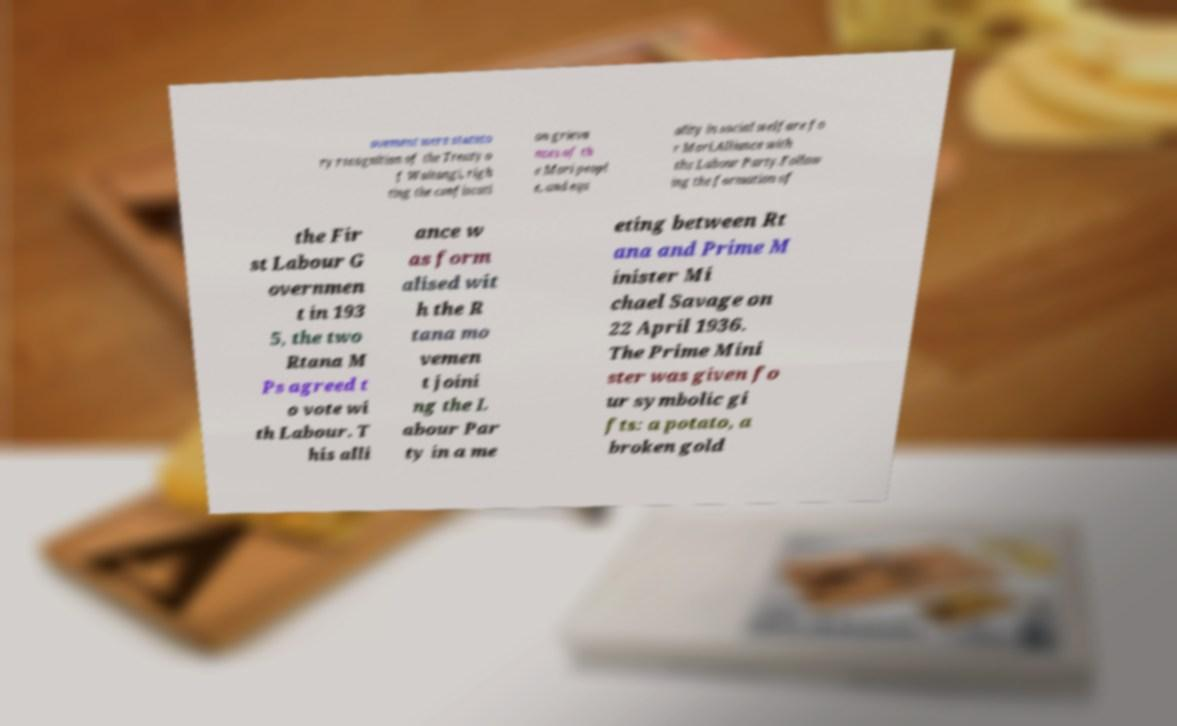For documentation purposes, I need the text within this image transcribed. Could you provide that? ovement were statuto ry recognition of the Treaty o f Waitangi, righ ting the confiscati on grieva nces of th e Mori peopl e, and equ ality in social welfare fo r Mori.Alliance with the Labour Party.Follow ing the formation of the Fir st Labour G overnmen t in 193 5, the two Rtana M Ps agreed t o vote wi th Labour. T his alli ance w as form alised wit h the R tana mo vemen t joini ng the L abour Par ty in a me eting between Rt ana and Prime M inister Mi chael Savage on 22 April 1936. The Prime Mini ster was given fo ur symbolic gi fts: a potato, a broken gold 